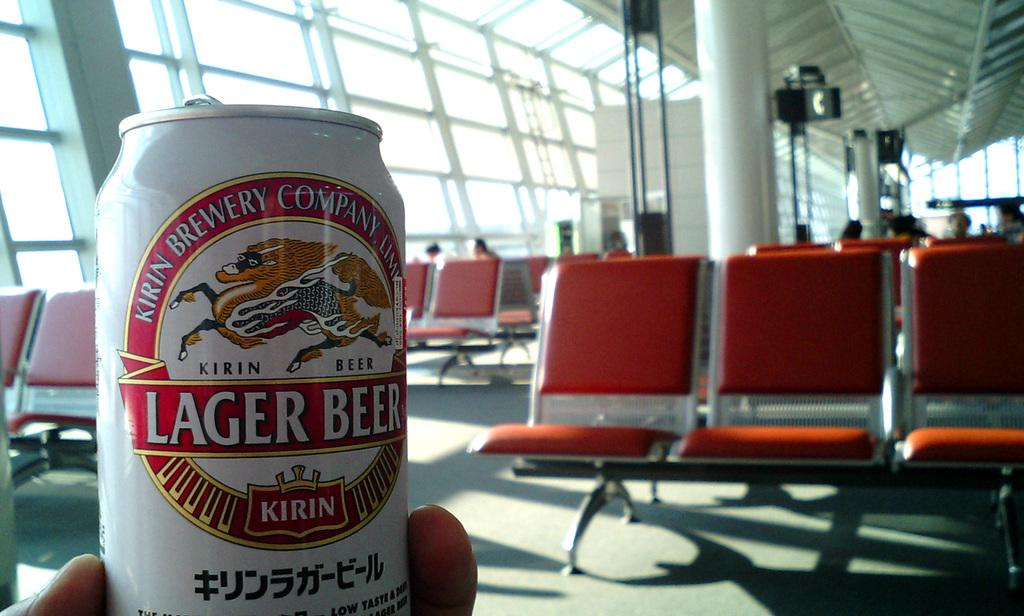<image>
Give a short and clear explanation of the subsequent image. Someone holds up a Kirin Lager Beer in an airport. 